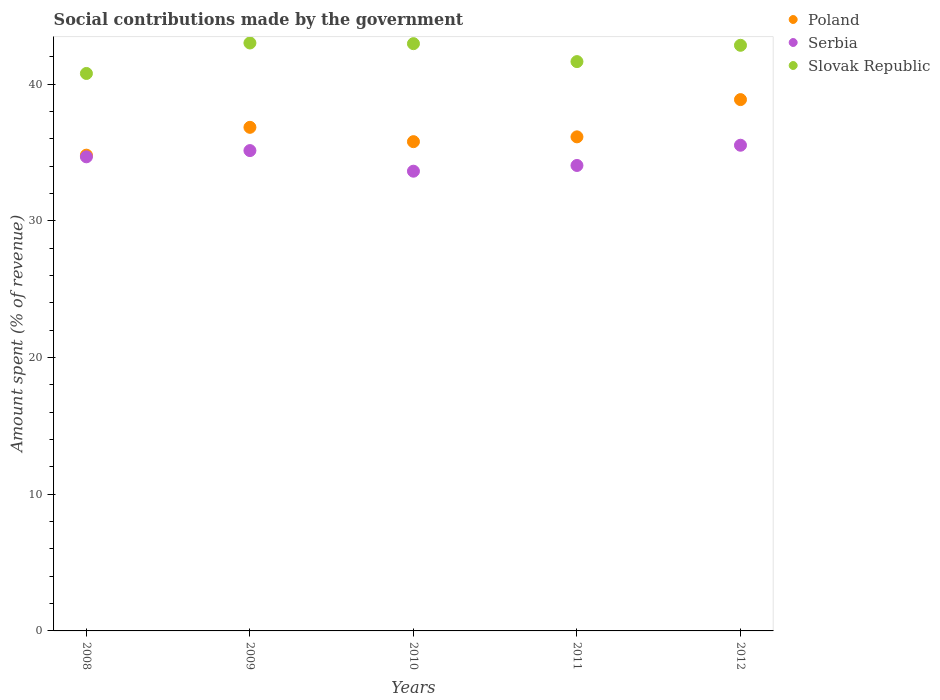How many different coloured dotlines are there?
Give a very brief answer. 3. What is the amount spent (in %) on social contributions in Poland in 2009?
Keep it short and to the point. 36.85. Across all years, what is the maximum amount spent (in %) on social contributions in Serbia?
Your answer should be compact. 35.54. Across all years, what is the minimum amount spent (in %) on social contributions in Poland?
Your answer should be very brief. 34.81. In which year was the amount spent (in %) on social contributions in Serbia maximum?
Your answer should be compact. 2012. What is the total amount spent (in %) on social contributions in Slovak Republic in the graph?
Your answer should be very brief. 211.28. What is the difference between the amount spent (in %) on social contributions in Slovak Republic in 2010 and that in 2011?
Provide a succinct answer. 1.31. What is the difference between the amount spent (in %) on social contributions in Serbia in 2009 and the amount spent (in %) on social contributions in Poland in 2008?
Your answer should be compact. 0.34. What is the average amount spent (in %) on social contributions in Serbia per year?
Keep it short and to the point. 34.61. In the year 2010, what is the difference between the amount spent (in %) on social contributions in Poland and amount spent (in %) on social contributions in Serbia?
Your response must be concise. 2.16. What is the ratio of the amount spent (in %) on social contributions in Slovak Republic in 2011 to that in 2012?
Provide a succinct answer. 0.97. Is the amount spent (in %) on social contributions in Slovak Republic in 2008 less than that in 2011?
Your answer should be compact. Yes. What is the difference between the highest and the second highest amount spent (in %) on social contributions in Serbia?
Make the answer very short. 0.39. What is the difference between the highest and the lowest amount spent (in %) on social contributions in Slovak Republic?
Offer a terse response. 2.23. Is the sum of the amount spent (in %) on social contributions in Poland in 2009 and 2011 greater than the maximum amount spent (in %) on social contributions in Serbia across all years?
Provide a short and direct response. Yes. Is it the case that in every year, the sum of the amount spent (in %) on social contributions in Slovak Republic and amount spent (in %) on social contributions in Poland  is greater than the amount spent (in %) on social contributions in Serbia?
Your answer should be very brief. Yes. Is the amount spent (in %) on social contributions in Slovak Republic strictly greater than the amount spent (in %) on social contributions in Poland over the years?
Keep it short and to the point. Yes. How many dotlines are there?
Your answer should be compact. 3. How many years are there in the graph?
Provide a succinct answer. 5. Are the values on the major ticks of Y-axis written in scientific E-notation?
Keep it short and to the point. No. Does the graph contain any zero values?
Give a very brief answer. No. Where does the legend appear in the graph?
Your response must be concise. Top right. How many legend labels are there?
Ensure brevity in your answer.  3. How are the legend labels stacked?
Provide a short and direct response. Vertical. What is the title of the graph?
Ensure brevity in your answer.  Social contributions made by the government. What is the label or title of the Y-axis?
Offer a terse response. Amount spent (% of revenue). What is the Amount spent (% of revenue) of Poland in 2008?
Ensure brevity in your answer.  34.81. What is the Amount spent (% of revenue) of Serbia in 2008?
Provide a succinct answer. 34.69. What is the Amount spent (% of revenue) of Slovak Republic in 2008?
Your answer should be very brief. 40.79. What is the Amount spent (% of revenue) of Poland in 2009?
Your answer should be compact. 36.85. What is the Amount spent (% of revenue) of Serbia in 2009?
Offer a terse response. 35.15. What is the Amount spent (% of revenue) in Slovak Republic in 2009?
Your response must be concise. 43.02. What is the Amount spent (% of revenue) in Poland in 2010?
Provide a short and direct response. 35.8. What is the Amount spent (% of revenue) of Serbia in 2010?
Your answer should be compact. 33.64. What is the Amount spent (% of revenue) of Slovak Republic in 2010?
Offer a very short reply. 42.97. What is the Amount spent (% of revenue) of Poland in 2011?
Give a very brief answer. 36.15. What is the Amount spent (% of revenue) in Serbia in 2011?
Give a very brief answer. 34.06. What is the Amount spent (% of revenue) in Slovak Republic in 2011?
Give a very brief answer. 41.66. What is the Amount spent (% of revenue) in Poland in 2012?
Give a very brief answer. 38.88. What is the Amount spent (% of revenue) of Serbia in 2012?
Your answer should be very brief. 35.54. What is the Amount spent (% of revenue) in Slovak Republic in 2012?
Make the answer very short. 42.85. Across all years, what is the maximum Amount spent (% of revenue) of Poland?
Give a very brief answer. 38.88. Across all years, what is the maximum Amount spent (% of revenue) in Serbia?
Offer a terse response. 35.54. Across all years, what is the maximum Amount spent (% of revenue) in Slovak Republic?
Offer a very short reply. 43.02. Across all years, what is the minimum Amount spent (% of revenue) of Poland?
Your answer should be compact. 34.81. Across all years, what is the minimum Amount spent (% of revenue) in Serbia?
Your response must be concise. 33.64. Across all years, what is the minimum Amount spent (% of revenue) in Slovak Republic?
Make the answer very short. 40.79. What is the total Amount spent (% of revenue) in Poland in the graph?
Ensure brevity in your answer.  182.48. What is the total Amount spent (% of revenue) in Serbia in the graph?
Offer a terse response. 173.07. What is the total Amount spent (% of revenue) of Slovak Republic in the graph?
Provide a succinct answer. 211.28. What is the difference between the Amount spent (% of revenue) in Poland in 2008 and that in 2009?
Provide a short and direct response. -2.04. What is the difference between the Amount spent (% of revenue) in Serbia in 2008 and that in 2009?
Offer a very short reply. -0.46. What is the difference between the Amount spent (% of revenue) in Slovak Republic in 2008 and that in 2009?
Ensure brevity in your answer.  -2.23. What is the difference between the Amount spent (% of revenue) in Poland in 2008 and that in 2010?
Provide a short and direct response. -0.99. What is the difference between the Amount spent (% of revenue) in Serbia in 2008 and that in 2010?
Your response must be concise. 1.05. What is the difference between the Amount spent (% of revenue) of Slovak Republic in 2008 and that in 2010?
Your response must be concise. -2.18. What is the difference between the Amount spent (% of revenue) in Poland in 2008 and that in 2011?
Provide a short and direct response. -1.34. What is the difference between the Amount spent (% of revenue) in Serbia in 2008 and that in 2011?
Your answer should be compact. 0.63. What is the difference between the Amount spent (% of revenue) in Slovak Republic in 2008 and that in 2011?
Give a very brief answer. -0.87. What is the difference between the Amount spent (% of revenue) in Poland in 2008 and that in 2012?
Provide a succinct answer. -4.07. What is the difference between the Amount spent (% of revenue) in Serbia in 2008 and that in 2012?
Your response must be concise. -0.85. What is the difference between the Amount spent (% of revenue) of Slovak Republic in 2008 and that in 2012?
Ensure brevity in your answer.  -2.06. What is the difference between the Amount spent (% of revenue) in Poland in 2009 and that in 2010?
Make the answer very short. 1.05. What is the difference between the Amount spent (% of revenue) of Serbia in 2009 and that in 2010?
Make the answer very short. 1.51. What is the difference between the Amount spent (% of revenue) in Slovak Republic in 2009 and that in 2010?
Make the answer very short. 0.05. What is the difference between the Amount spent (% of revenue) in Poland in 2009 and that in 2011?
Offer a very short reply. 0.7. What is the difference between the Amount spent (% of revenue) of Serbia in 2009 and that in 2011?
Offer a terse response. 1.09. What is the difference between the Amount spent (% of revenue) of Slovak Republic in 2009 and that in 2011?
Keep it short and to the point. 1.36. What is the difference between the Amount spent (% of revenue) in Poland in 2009 and that in 2012?
Give a very brief answer. -2.03. What is the difference between the Amount spent (% of revenue) in Serbia in 2009 and that in 2012?
Ensure brevity in your answer.  -0.39. What is the difference between the Amount spent (% of revenue) in Slovak Republic in 2009 and that in 2012?
Ensure brevity in your answer.  0.17. What is the difference between the Amount spent (% of revenue) of Poland in 2010 and that in 2011?
Your response must be concise. -0.35. What is the difference between the Amount spent (% of revenue) of Serbia in 2010 and that in 2011?
Provide a short and direct response. -0.42. What is the difference between the Amount spent (% of revenue) in Slovak Republic in 2010 and that in 2011?
Offer a very short reply. 1.31. What is the difference between the Amount spent (% of revenue) in Poland in 2010 and that in 2012?
Offer a terse response. -3.08. What is the difference between the Amount spent (% of revenue) of Serbia in 2010 and that in 2012?
Your response must be concise. -1.9. What is the difference between the Amount spent (% of revenue) of Slovak Republic in 2010 and that in 2012?
Your answer should be very brief. 0.12. What is the difference between the Amount spent (% of revenue) of Poland in 2011 and that in 2012?
Give a very brief answer. -2.73. What is the difference between the Amount spent (% of revenue) of Serbia in 2011 and that in 2012?
Provide a short and direct response. -1.48. What is the difference between the Amount spent (% of revenue) in Slovak Republic in 2011 and that in 2012?
Your answer should be compact. -1.19. What is the difference between the Amount spent (% of revenue) of Poland in 2008 and the Amount spent (% of revenue) of Serbia in 2009?
Ensure brevity in your answer.  -0.34. What is the difference between the Amount spent (% of revenue) in Poland in 2008 and the Amount spent (% of revenue) in Slovak Republic in 2009?
Your answer should be very brief. -8.21. What is the difference between the Amount spent (% of revenue) of Serbia in 2008 and the Amount spent (% of revenue) of Slovak Republic in 2009?
Provide a succinct answer. -8.33. What is the difference between the Amount spent (% of revenue) of Poland in 2008 and the Amount spent (% of revenue) of Serbia in 2010?
Your answer should be compact. 1.17. What is the difference between the Amount spent (% of revenue) of Poland in 2008 and the Amount spent (% of revenue) of Slovak Republic in 2010?
Make the answer very short. -8.16. What is the difference between the Amount spent (% of revenue) in Serbia in 2008 and the Amount spent (% of revenue) in Slovak Republic in 2010?
Give a very brief answer. -8.28. What is the difference between the Amount spent (% of revenue) in Poland in 2008 and the Amount spent (% of revenue) in Serbia in 2011?
Keep it short and to the point. 0.75. What is the difference between the Amount spent (% of revenue) of Poland in 2008 and the Amount spent (% of revenue) of Slovak Republic in 2011?
Provide a succinct answer. -6.85. What is the difference between the Amount spent (% of revenue) of Serbia in 2008 and the Amount spent (% of revenue) of Slovak Republic in 2011?
Provide a succinct answer. -6.97. What is the difference between the Amount spent (% of revenue) of Poland in 2008 and the Amount spent (% of revenue) of Serbia in 2012?
Provide a succinct answer. -0.73. What is the difference between the Amount spent (% of revenue) of Poland in 2008 and the Amount spent (% of revenue) of Slovak Republic in 2012?
Ensure brevity in your answer.  -8.04. What is the difference between the Amount spent (% of revenue) in Serbia in 2008 and the Amount spent (% of revenue) in Slovak Republic in 2012?
Make the answer very short. -8.16. What is the difference between the Amount spent (% of revenue) in Poland in 2009 and the Amount spent (% of revenue) in Serbia in 2010?
Keep it short and to the point. 3.21. What is the difference between the Amount spent (% of revenue) of Poland in 2009 and the Amount spent (% of revenue) of Slovak Republic in 2010?
Offer a very short reply. -6.12. What is the difference between the Amount spent (% of revenue) in Serbia in 2009 and the Amount spent (% of revenue) in Slovak Republic in 2010?
Give a very brief answer. -7.82. What is the difference between the Amount spent (% of revenue) in Poland in 2009 and the Amount spent (% of revenue) in Serbia in 2011?
Your answer should be very brief. 2.79. What is the difference between the Amount spent (% of revenue) in Poland in 2009 and the Amount spent (% of revenue) in Slovak Republic in 2011?
Provide a short and direct response. -4.81. What is the difference between the Amount spent (% of revenue) of Serbia in 2009 and the Amount spent (% of revenue) of Slovak Republic in 2011?
Give a very brief answer. -6.51. What is the difference between the Amount spent (% of revenue) in Poland in 2009 and the Amount spent (% of revenue) in Serbia in 2012?
Provide a succinct answer. 1.31. What is the difference between the Amount spent (% of revenue) in Poland in 2009 and the Amount spent (% of revenue) in Slovak Republic in 2012?
Your response must be concise. -6. What is the difference between the Amount spent (% of revenue) of Serbia in 2009 and the Amount spent (% of revenue) of Slovak Republic in 2012?
Your response must be concise. -7.7. What is the difference between the Amount spent (% of revenue) in Poland in 2010 and the Amount spent (% of revenue) in Serbia in 2011?
Your answer should be very brief. 1.74. What is the difference between the Amount spent (% of revenue) in Poland in 2010 and the Amount spent (% of revenue) in Slovak Republic in 2011?
Your answer should be compact. -5.86. What is the difference between the Amount spent (% of revenue) in Serbia in 2010 and the Amount spent (% of revenue) in Slovak Republic in 2011?
Keep it short and to the point. -8.02. What is the difference between the Amount spent (% of revenue) of Poland in 2010 and the Amount spent (% of revenue) of Serbia in 2012?
Your answer should be compact. 0.26. What is the difference between the Amount spent (% of revenue) in Poland in 2010 and the Amount spent (% of revenue) in Slovak Republic in 2012?
Provide a succinct answer. -7.05. What is the difference between the Amount spent (% of revenue) in Serbia in 2010 and the Amount spent (% of revenue) in Slovak Republic in 2012?
Provide a short and direct response. -9.21. What is the difference between the Amount spent (% of revenue) in Poland in 2011 and the Amount spent (% of revenue) in Serbia in 2012?
Provide a short and direct response. 0.61. What is the difference between the Amount spent (% of revenue) of Poland in 2011 and the Amount spent (% of revenue) of Slovak Republic in 2012?
Your answer should be very brief. -6.7. What is the difference between the Amount spent (% of revenue) in Serbia in 2011 and the Amount spent (% of revenue) in Slovak Republic in 2012?
Your answer should be very brief. -8.79. What is the average Amount spent (% of revenue) in Poland per year?
Offer a terse response. 36.5. What is the average Amount spent (% of revenue) of Serbia per year?
Ensure brevity in your answer.  34.61. What is the average Amount spent (% of revenue) of Slovak Republic per year?
Give a very brief answer. 42.26. In the year 2008, what is the difference between the Amount spent (% of revenue) of Poland and Amount spent (% of revenue) of Serbia?
Your answer should be very brief. 0.12. In the year 2008, what is the difference between the Amount spent (% of revenue) in Poland and Amount spent (% of revenue) in Slovak Republic?
Your answer should be compact. -5.98. In the year 2008, what is the difference between the Amount spent (% of revenue) of Serbia and Amount spent (% of revenue) of Slovak Republic?
Provide a short and direct response. -6.1. In the year 2009, what is the difference between the Amount spent (% of revenue) of Poland and Amount spent (% of revenue) of Serbia?
Keep it short and to the point. 1.7. In the year 2009, what is the difference between the Amount spent (% of revenue) in Poland and Amount spent (% of revenue) in Slovak Republic?
Your answer should be compact. -6.17. In the year 2009, what is the difference between the Amount spent (% of revenue) of Serbia and Amount spent (% of revenue) of Slovak Republic?
Keep it short and to the point. -7.87. In the year 2010, what is the difference between the Amount spent (% of revenue) in Poland and Amount spent (% of revenue) in Serbia?
Your answer should be compact. 2.16. In the year 2010, what is the difference between the Amount spent (% of revenue) of Poland and Amount spent (% of revenue) of Slovak Republic?
Offer a terse response. -7.17. In the year 2010, what is the difference between the Amount spent (% of revenue) of Serbia and Amount spent (% of revenue) of Slovak Republic?
Offer a terse response. -9.33. In the year 2011, what is the difference between the Amount spent (% of revenue) in Poland and Amount spent (% of revenue) in Serbia?
Provide a short and direct response. 2.09. In the year 2011, what is the difference between the Amount spent (% of revenue) of Poland and Amount spent (% of revenue) of Slovak Republic?
Your response must be concise. -5.51. In the year 2011, what is the difference between the Amount spent (% of revenue) of Serbia and Amount spent (% of revenue) of Slovak Republic?
Your answer should be compact. -7.6. In the year 2012, what is the difference between the Amount spent (% of revenue) of Poland and Amount spent (% of revenue) of Serbia?
Ensure brevity in your answer.  3.34. In the year 2012, what is the difference between the Amount spent (% of revenue) in Poland and Amount spent (% of revenue) in Slovak Republic?
Your answer should be very brief. -3.97. In the year 2012, what is the difference between the Amount spent (% of revenue) of Serbia and Amount spent (% of revenue) of Slovak Republic?
Your response must be concise. -7.31. What is the ratio of the Amount spent (% of revenue) of Poland in 2008 to that in 2009?
Keep it short and to the point. 0.94. What is the ratio of the Amount spent (% of revenue) in Slovak Republic in 2008 to that in 2009?
Your answer should be very brief. 0.95. What is the ratio of the Amount spent (% of revenue) of Poland in 2008 to that in 2010?
Provide a short and direct response. 0.97. What is the ratio of the Amount spent (% of revenue) of Serbia in 2008 to that in 2010?
Your answer should be compact. 1.03. What is the ratio of the Amount spent (% of revenue) of Slovak Republic in 2008 to that in 2010?
Offer a very short reply. 0.95. What is the ratio of the Amount spent (% of revenue) in Poland in 2008 to that in 2011?
Offer a terse response. 0.96. What is the ratio of the Amount spent (% of revenue) in Serbia in 2008 to that in 2011?
Your answer should be compact. 1.02. What is the ratio of the Amount spent (% of revenue) in Slovak Republic in 2008 to that in 2011?
Keep it short and to the point. 0.98. What is the ratio of the Amount spent (% of revenue) in Poland in 2008 to that in 2012?
Offer a terse response. 0.9. What is the ratio of the Amount spent (% of revenue) of Serbia in 2008 to that in 2012?
Make the answer very short. 0.98. What is the ratio of the Amount spent (% of revenue) in Slovak Republic in 2008 to that in 2012?
Keep it short and to the point. 0.95. What is the ratio of the Amount spent (% of revenue) of Poland in 2009 to that in 2010?
Your response must be concise. 1.03. What is the ratio of the Amount spent (% of revenue) in Serbia in 2009 to that in 2010?
Provide a short and direct response. 1.04. What is the ratio of the Amount spent (% of revenue) in Slovak Republic in 2009 to that in 2010?
Your answer should be compact. 1. What is the ratio of the Amount spent (% of revenue) of Poland in 2009 to that in 2011?
Provide a short and direct response. 1.02. What is the ratio of the Amount spent (% of revenue) in Serbia in 2009 to that in 2011?
Your answer should be very brief. 1.03. What is the ratio of the Amount spent (% of revenue) in Slovak Republic in 2009 to that in 2011?
Offer a very short reply. 1.03. What is the ratio of the Amount spent (% of revenue) of Poland in 2009 to that in 2012?
Provide a succinct answer. 0.95. What is the ratio of the Amount spent (% of revenue) of Serbia in 2009 to that in 2012?
Offer a very short reply. 0.99. What is the ratio of the Amount spent (% of revenue) of Slovak Republic in 2009 to that in 2012?
Your answer should be compact. 1. What is the ratio of the Amount spent (% of revenue) of Poland in 2010 to that in 2011?
Your answer should be compact. 0.99. What is the ratio of the Amount spent (% of revenue) in Slovak Republic in 2010 to that in 2011?
Your answer should be compact. 1.03. What is the ratio of the Amount spent (% of revenue) in Poland in 2010 to that in 2012?
Provide a succinct answer. 0.92. What is the ratio of the Amount spent (% of revenue) of Serbia in 2010 to that in 2012?
Provide a short and direct response. 0.95. What is the ratio of the Amount spent (% of revenue) of Slovak Republic in 2010 to that in 2012?
Keep it short and to the point. 1. What is the ratio of the Amount spent (% of revenue) of Poland in 2011 to that in 2012?
Your answer should be compact. 0.93. What is the ratio of the Amount spent (% of revenue) in Slovak Republic in 2011 to that in 2012?
Make the answer very short. 0.97. What is the difference between the highest and the second highest Amount spent (% of revenue) of Poland?
Offer a very short reply. 2.03. What is the difference between the highest and the second highest Amount spent (% of revenue) in Serbia?
Ensure brevity in your answer.  0.39. What is the difference between the highest and the second highest Amount spent (% of revenue) of Slovak Republic?
Offer a very short reply. 0.05. What is the difference between the highest and the lowest Amount spent (% of revenue) in Poland?
Provide a succinct answer. 4.07. What is the difference between the highest and the lowest Amount spent (% of revenue) in Serbia?
Offer a terse response. 1.9. What is the difference between the highest and the lowest Amount spent (% of revenue) in Slovak Republic?
Give a very brief answer. 2.23. 